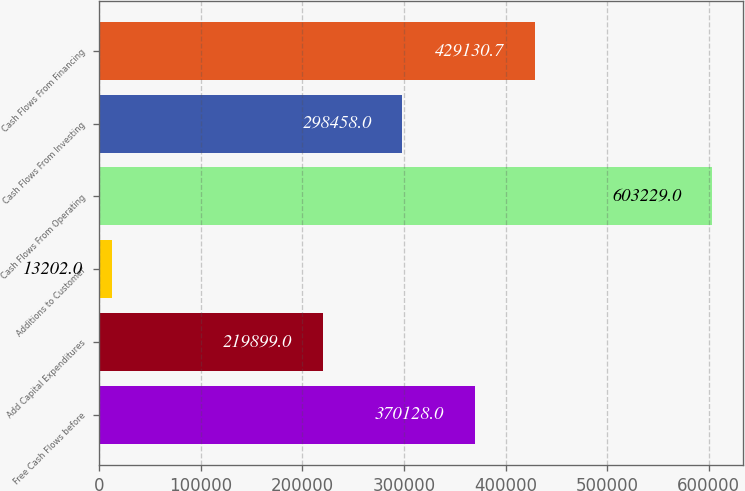<chart> <loc_0><loc_0><loc_500><loc_500><bar_chart><fcel>Free Cash Flows before<fcel>Add Capital Expenditures<fcel>Additions to Customer<fcel>Cash Flows From Operating<fcel>Cash Flows From Investing<fcel>Cash Flows From Financing<nl><fcel>370128<fcel>219899<fcel>13202<fcel>603229<fcel>298458<fcel>429131<nl></chart> 